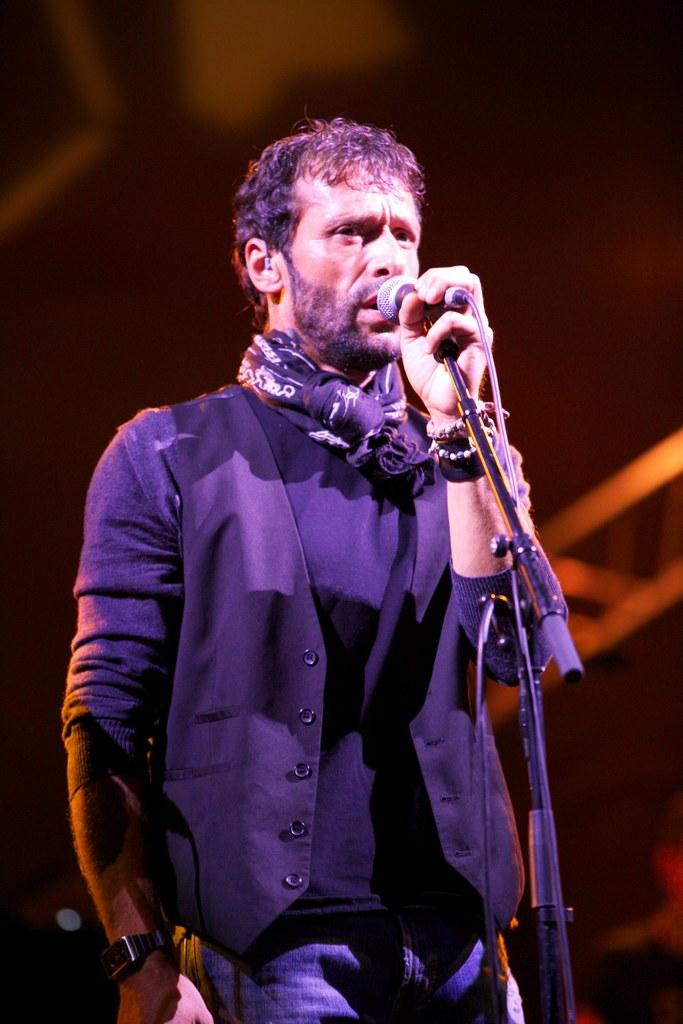Who is the main subject in the image? There is a person in the image. What is the person doing in the image? The person is standing in front of a mic. What is the person wearing in the image? The person is wearing a black color dress. What is the person holding in the image? The person is holding the mic. What level of respect is shown by the person in the image? The image does not provide information about the level of respect shown by the person. The focus is on the person's actions and attire, not their behavior or attitude. 